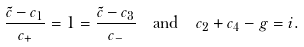Convert formula to latex. <formula><loc_0><loc_0><loc_500><loc_500>\frac { \tilde { c } - c _ { 1 } } { c _ { + } } = 1 & = \frac { \tilde { c } - c _ { 3 } } { c _ { - } } \quad \text {and} \quad c _ { 2 } + c _ { 4 } - g = i .</formula> 